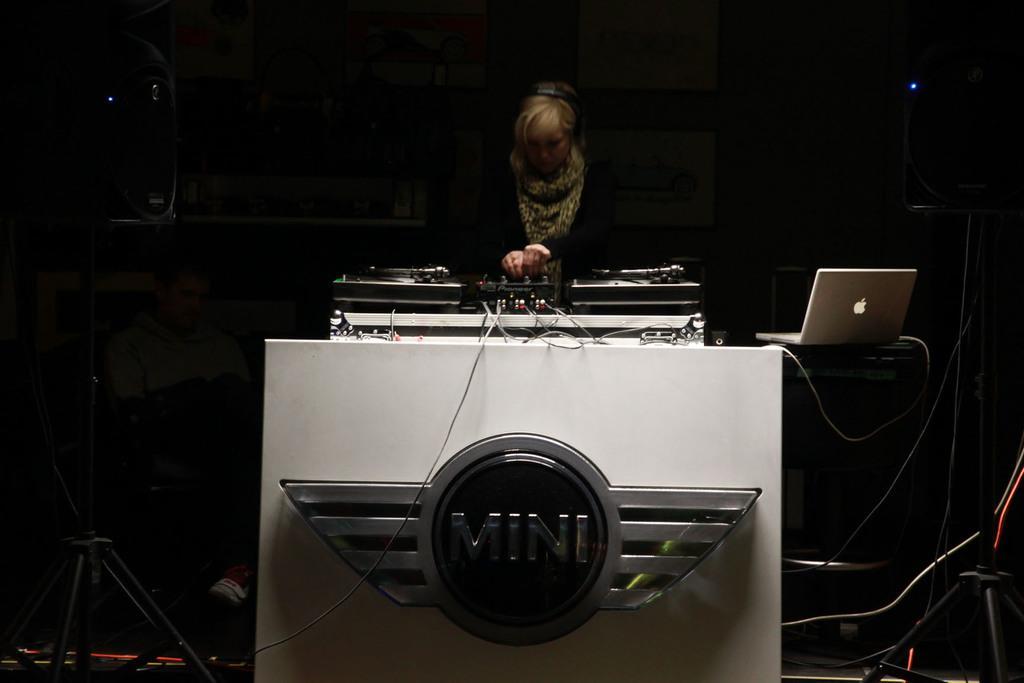Please provide a concise description of this image. This image consists of a woman playing a DJ. In the front, we can see a logo. On the right, there is a laptop. And the background is too dark. 